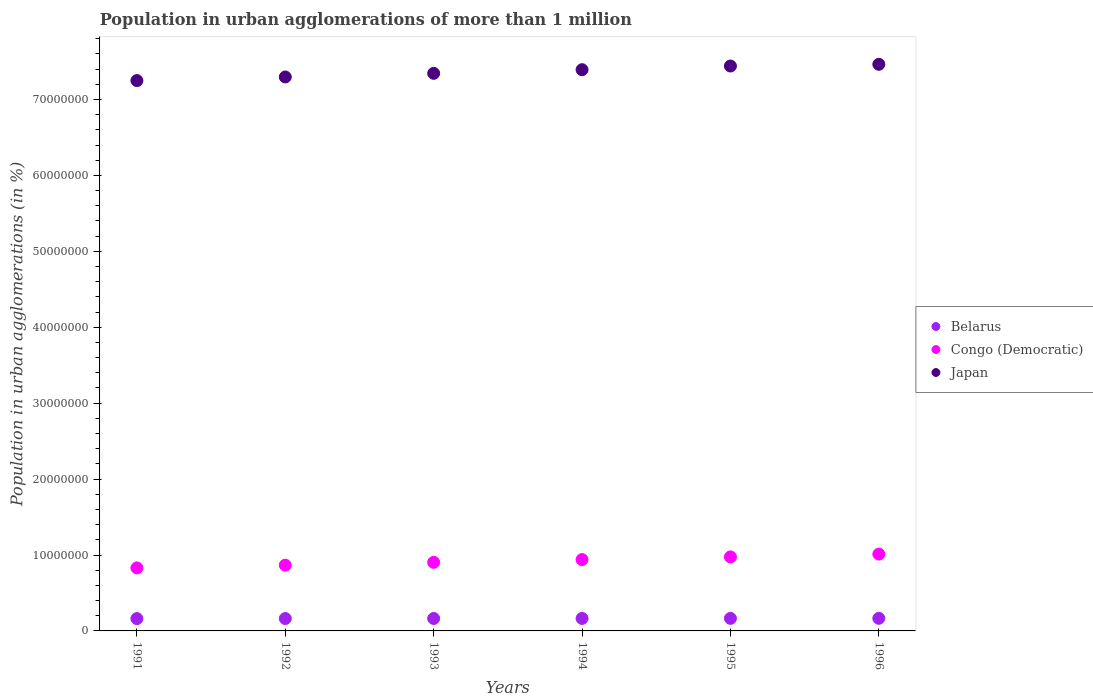Is the number of dotlines equal to the number of legend labels?
Offer a very short reply. Yes. What is the population in urban agglomerations in Japan in 1996?
Ensure brevity in your answer.  7.46e+07. Across all years, what is the maximum population in urban agglomerations in Japan?
Keep it short and to the point. 7.46e+07. Across all years, what is the minimum population in urban agglomerations in Belarus?
Your answer should be very brief. 1.62e+06. In which year was the population in urban agglomerations in Belarus minimum?
Give a very brief answer. 1991. What is the total population in urban agglomerations in Japan in the graph?
Make the answer very short. 4.42e+08. What is the difference between the population in urban agglomerations in Congo (Democratic) in 1991 and that in 1992?
Keep it short and to the point. -3.58e+05. What is the difference between the population in urban agglomerations in Congo (Democratic) in 1993 and the population in urban agglomerations in Belarus in 1994?
Provide a short and direct response. 7.39e+06. What is the average population in urban agglomerations in Belarus per year?
Offer a terse response. 1.64e+06. In the year 1996, what is the difference between the population in urban agglomerations in Belarus and population in urban agglomerations in Japan?
Your answer should be very brief. -7.30e+07. In how many years, is the population in urban agglomerations in Congo (Democratic) greater than 48000000 %?
Keep it short and to the point. 0. What is the ratio of the population in urban agglomerations in Congo (Democratic) in 1994 to that in 1996?
Your response must be concise. 0.93. Is the population in urban agglomerations in Japan in 1992 less than that in 1995?
Your answer should be very brief. Yes. What is the difference between the highest and the second highest population in urban agglomerations in Japan?
Make the answer very short. 2.27e+05. What is the difference between the highest and the lowest population in urban agglomerations in Congo (Democratic)?
Ensure brevity in your answer.  1.82e+06. In how many years, is the population in urban agglomerations in Belarus greater than the average population in urban agglomerations in Belarus taken over all years?
Make the answer very short. 3. Does the population in urban agglomerations in Congo (Democratic) monotonically increase over the years?
Provide a succinct answer. Yes. Is the population in urban agglomerations in Belarus strictly greater than the population in urban agglomerations in Japan over the years?
Provide a succinct answer. No. How many dotlines are there?
Make the answer very short. 3. Where does the legend appear in the graph?
Keep it short and to the point. Center right. What is the title of the graph?
Offer a terse response. Population in urban agglomerations of more than 1 million. Does "Aruba" appear as one of the legend labels in the graph?
Offer a very short reply. No. What is the label or title of the X-axis?
Offer a terse response. Years. What is the label or title of the Y-axis?
Keep it short and to the point. Population in urban agglomerations (in %). What is the Population in urban agglomerations (in %) of Belarus in 1991?
Ensure brevity in your answer.  1.62e+06. What is the Population in urban agglomerations (in %) of Congo (Democratic) in 1991?
Offer a terse response. 8.30e+06. What is the Population in urban agglomerations (in %) in Japan in 1991?
Make the answer very short. 7.25e+07. What is the Population in urban agglomerations (in %) of Belarus in 1992?
Give a very brief answer. 1.63e+06. What is the Population in urban agglomerations (in %) of Congo (Democratic) in 1992?
Provide a succinct answer. 8.66e+06. What is the Population in urban agglomerations (in %) of Japan in 1992?
Make the answer very short. 7.30e+07. What is the Population in urban agglomerations (in %) in Belarus in 1993?
Your answer should be compact. 1.64e+06. What is the Population in urban agglomerations (in %) in Congo (Democratic) in 1993?
Your answer should be compact. 9.04e+06. What is the Population in urban agglomerations (in %) in Japan in 1993?
Your answer should be very brief. 7.34e+07. What is the Population in urban agglomerations (in %) of Belarus in 1994?
Keep it short and to the point. 1.65e+06. What is the Population in urban agglomerations (in %) of Congo (Democratic) in 1994?
Give a very brief answer. 9.40e+06. What is the Population in urban agglomerations (in %) of Japan in 1994?
Provide a succinct answer. 7.39e+07. What is the Population in urban agglomerations (in %) of Belarus in 1995?
Provide a short and direct response. 1.65e+06. What is the Population in urban agglomerations (in %) in Congo (Democratic) in 1995?
Provide a succinct answer. 9.75e+06. What is the Population in urban agglomerations (in %) in Japan in 1995?
Give a very brief answer. 7.44e+07. What is the Population in urban agglomerations (in %) in Belarus in 1996?
Keep it short and to the point. 1.66e+06. What is the Population in urban agglomerations (in %) in Congo (Democratic) in 1996?
Your answer should be compact. 1.01e+07. What is the Population in urban agglomerations (in %) in Japan in 1996?
Your response must be concise. 7.46e+07. Across all years, what is the maximum Population in urban agglomerations (in %) of Belarus?
Make the answer very short. 1.66e+06. Across all years, what is the maximum Population in urban agglomerations (in %) in Congo (Democratic)?
Ensure brevity in your answer.  1.01e+07. Across all years, what is the maximum Population in urban agglomerations (in %) of Japan?
Provide a short and direct response. 7.46e+07. Across all years, what is the minimum Population in urban agglomerations (in %) in Belarus?
Your answer should be compact. 1.62e+06. Across all years, what is the minimum Population in urban agglomerations (in %) in Congo (Democratic)?
Offer a terse response. 8.30e+06. Across all years, what is the minimum Population in urban agglomerations (in %) in Japan?
Your answer should be very brief. 7.25e+07. What is the total Population in urban agglomerations (in %) in Belarus in the graph?
Make the answer very short. 9.86e+06. What is the total Population in urban agglomerations (in %) in Congo (Democratic) in the graph?
Keep it short and to the point. 5.53e+07. What is the total Population in urban agglomerations (in %) of Japan in the graph?
Your response must be concise. 4.42e+08. What is the difference between the Population in urban agglomerations (in %) of Belarus in 1991 and that in 1992?
Provide a succinct answer. -7221. What is the difference between the Population in urban agglomerations (in %) in Congo (Democratic) in 1991 and that in 1992?
Provide a succinct answer. -3.58e+05. What is the difference between the Population in urban agglomerations (in %) of Japan in 1991 and that in 1992?
Ensure brevity in your answer.  -4.75e+05. What is the difference between the Population in urban agglomerations (in %) of Belarus in 1991 and that in 1993?
Give a very brief answer. -1.45e+04. What is the difference between the Population in urban agglomerations (in %) of Congo (Democratic) in 1991 and that in 1993?
Provide a short and direct response. -7.33e+05. What is the difference between the Population in urban agglomerations (in %) in Japan in 1991 and that in 1993?
Your answer should be compact. -9.52e+05. What is the difference between the Population in urban agglomerations (in %) in Belarus in 1991 and that in 1994?
Ensure brevity in your answer.  -2.17e+04. What is the difference between the Population in urban agglomerations (in %) of Congo (Democratic) in 1991 and that in 1994?
Offer a terse response. -1.10e+06. What is the difference between the Population in urban agglomerations (in %) of Japan in 1991 and that in 1994?
Make the answer very short. -1.43e+06. What is the difference between the Population in urban agglomerations (in %) in Belarus in 1991 and that in 1995?
Provide a short and direct response. -2.90e+04. What is the difference between the Population in urban agglomerations (in %) in Congo (Democratic) in 1991 and that in 1995?
Offer a terse response. -1.45e+06. What is the difference between the Population in urban agglomerations (in %) of Japan in 1991 and that in 1995?
Make the answer very short. -1.92e+06. What is the difference between the Population in urban agglomerations (in %) of Belarus in 1991 and that in 1996?
Give a very brief answer. -3.64e+04. What is the difference between the Population in urban agglomerations (in %) of Congo (Democratic) in 1991 and that in 1996?
Keep it short and to the point. -1.82e+06. What is the difference between the Population in urban agglomerations (in %) of Japan in 1991 and that in 1996?
Make the answer very short. -2.15e+06. What is the difference between the Population in urban agglomerations (in %) of Belarus in 1992 and that in 1993?
Provide a short and direct response. -7234. What is the difference between the Population in urban agglomerations (in %) of Congo (Democratic) in 1992 and that in 1993?
Provide a short and direct response. -3.74e+05. What is the difference between the Population in urban agglomerations (in %) of Japan in 1992 and that in 1993?
Keep it short and to the point. -4.77e+05. What is the difference between the Population in urban agglomerations (in %) of Belarus in 1992 and that in 1994?
Your answer should be compact. -1.45e+04. What is the difference between the Population in urban agglomerations (in %) in Congo (Democratic) in 1992 and that in 1994?
Give a very brief answer. -7.38e+05. What is the difference between the Population in urban agglomerations (in %) in Japan in 1992 and that in 1994?
Provide a short and direct response. -9.58e+05. What is the difference between the Population in urban agglomerations (in %) in Belarus in 1992 and that in 1995?
Offer a terse response. -2.18e+04. What is the difference between the Population in urban agglomerations (in %) in Congo (Democratic) in 1992 and that in 1995?
Make the answer very short. -1.09e+06. What is the difference between the Population in urban agglomerations (in %) in Japan in 1992 and that in 1995?
Provide a succinct answer. -1.44e+06. What is the difference between the Population in urban agglomerations (in %) of Belarus in 1992 and that in 1996?
Provide a succinct answer. -2.92e+04. What is the difference between the Population in urban agglomerations (in %) in Congo (Democratic) in 1992 and that in 1996?
Keep it short and to the point. -1.46e+06. What is the difference between the Population in urban agglomerations (in %) in Japan in 1992 and that in 1996?
Give a very brief answer. -1.67e+06. What is the difference between the Population in urban agglomerations (in %) in Belarus in 1993 and that in 1994?
Offer a very short reply. -7276. What is the difference between the Population in urban agglomerations (in %) of Congo (Democratic) in 1993 and that in 1994?
Provide a short and direct response. -3.63e+05. What is the difference between the Population in urban agglomerations (in %) of Japan in 1993 and that in 1994?
Your answer should be very brief. -4.81e+05. What is the difference between the Population in urban agglomerations (in %) in Belarus in 1993 and that in 1995?
Keep it short and to the point. -1.46e+04. What is the difference between the Population in urban agglomerations (in %) of Congo (Democratic) in 1993 and that in 1995?
Provide a short and direct response. -7.15e+05. What is the difference between the Population in urban agglomerations (in %) of Japan in 1993 and that in 1995?
Provide a succinct answer. -9.65e+05. What is the difference between the Population in urban agglomerations (in %) in Belarus in 1993 and that in 1996?
Your answer should be compact. -2.19e+04. What is the difference between the Population in urban agglomerations (in %) in Congo (Democratic) in 1993 and that in 1996?
Provide a short and direct response. -1.09e+06. What is the difference between the Population in urban agglomerations (in %) of Japan in 1993 and that in 1996?
Provide a succinct answer. -1.19e+06. What is the difference between the Population in urban agglomerations (in %) in Belarus in 1994 and that in 1995?
Your response must be concise. -7308. What is the difference between the Population in urban agglomerations (in %) in Congo (Democratic) in 1994 and that in 1995?
Provide a short and direct response. -3.52e+05. What is the difference between the Population in urban agglomerations (in %) in Japan in 1994 and that in 1995?
Provide a short and direct response. -4.84e+05. What is the difference between the Population in urban agglomerations (in %) in Belarus in 1994 and that in 1996?
Your answer should be very brief. -1.47e+04. What is the difference between the Population in urban agglomerations (in %) of Congo (Democratic) in 1994 and that in 1996?
Your response must be concise. -7.22e+05. What is the difference between the Population in urban agglomerations (in %) in Japan in 1994 and that in 1996?
Provide a succinct answer. -7.12e+05. What is the difference between the Population in urban agglomerations (in %) in Belarus in 1995 and that in 1996?
Your answer should be compact. -7351. What is the difference between the Population in urban agglomerations (in %) of Congo (Democratic) in 1995 and that in 1996?
Offer a terse response. -3.70e+05. What is the difference between the Population in urban agglomerations (in %) in Japan in 1995 and that in 1996?
Your answer should be compact. -2.27e+05. What is the difference between the Population in urban agglomerations (in %) of Belarus in 1991 and the Population in urban agglomerations (in %) of Congo (Democratic) in 1992?
Ensure brevity in your answer.  -7.04e+06. What is the difference between the Population in urban agglomerations (in %) in Belarus in 1991 and the Population in urban agglomerations (in %) in Japan in 1992?
Make the answer very short. -7.13e+07. What is the difference between the Population in urban agglomerations (in %) in Congo (Democratic) in 1991 and the Population in urban agglomerations (in %) in Japan in 1992?
Your response must be concise. -6.47e+07. What is the difference between the Population in urban agglomerations (in %) in Belarus in 1991 and the Population in urban agglomerations (in %) in Congo (Democratic) in 1993?
Your answer should be very brief. -7.41e+06. What is the difference between the Population in urban agglomerations (in %) of Belarus in 1991 and the Population in urban agglomerations (in %) of Japan in 1993?
Provide a short and direct response. -7.18e+07. What is the difference between the Population in urban agglomerations (in %) of Congo (Democratic) in 1991 and the Population in urban agglomerations (in %) of Japan in 1993?
Offer a very short reply. -6.51e+07. What is the difference between the Population in urban agglomerations (in %) in Belarus in 1991 and the Population in urban agglomerations (in %) in Congo (Democratic) in 1994?
Provide a succinct answer. -7.77e+06. What is the difference between the Population in urban agglomerations (in %) of Belarus in 1991 and the Population in urban agglomerations (in %) of Japan in 1994?
Offer a terse response. -7.23e+07. What is the difference between the Population in urban agglomerations (in %) in Congo (Democratic) in 1991 and the Population in urban agglomerations (in %) in Japan in 1994?
Offer a very short reply. -6.56e+07. What is the difference between the Population in urban agglomerations (in %) of Belarus in 1991 and the Population in urban agglomerations (in %) of Congo (Democratic) in 1995?
Make the answer very short. -8.13e+06. What is the difference between the Population in urban agglomerations (in %) in Belarus in 1991 and the Population in urban agglomerations (in %) in Japan in 1995?
Your answer should be very brief. -7.28e+07. What is the difference between the Population in urban agglomerations (in %) in Congo (Democratic) in 1991 and the Population in urban agglomerations (in %) in Japan in 1995?
Make the answer very short. -6.61e+07. What is the difference between the Population in urban agglomerations (in %) of Belarus in 1991 and the Population in urban agglomerations (in %) of Congo (Democratic) in 1996?
Keep it short and to the point. -8.50e+06. What is the difference between the Population in urban agglomerations (in %) of Belarus in 1991 and the Population in urban agglomerations (in %) of Japan in 1996?
Your answer should be very brief. -7.30e+07. What is the difference between the Population in urban agglomerations (in %) of Congo (Democratic) in 1991 and the Population in urban agglomerations (in %) of Japan in 1996?
Offer a terse response. -6.63e+07. What is the difference between the Population in urban agglomerations (in %) of Belarus in 1992 and the Population in urban agglomerations (in %) of Congo (Democratic) in 1993?
Ensure brevity in your answer.  -7.40e+06. What is the difference between the Population in urban agglomerations (in %) in Belarus in 1992 and the Population in urban agglomerations (in %) in Japan in 1993?
Your answer should be very brief. -7.18e+07. What is the difference between the Population in urban agglomerations (in %) in Congo (Democratic) in 1992 and the Population in urban agglomerations (in %) in Japan in 1993?
Provide a succinct answer. -6.48e+07. What is the difference between the Population in urban agglomerations (in %) in Belarus in 1992 and the Population in urban agglomerations (in %) in Congo (Democratic) in 1994?
Give a very brief answer. -7.77e+06. What is the difference between the Population in urban agglomerations (in %) in Belarus in 1992 and the Population in urban agglomerations (in %) in Japan in 1994?
Make the answer very short. -7.23e+07. What is the difference between the Population in urban agglomerations (in %) in Congo (Democratic) in 1992 and the Population in urban agglomerations (in %) in Japan in 1994?
Your answer should be compact. -6.53e+07. What is the difference between the Population in urban agglomerations (in %) of Belarus in 1992 and the Population in urban agglomerations (in %) of Congo (Democratic) in 1995?
Your answer should be very brief. -8.12e+06. What is the difference between the Population in urban agglomerations (in %) of Belarus in 1992 and the Population in urban agglomerations (in %) of Japan in 1995?
Your response must be concise. -7.28e+07. What is the difference between the Population in urban agglomerations (in %) of Congo (Democratic) in 1992 and the Population in urban agglomerations (in %) of Japan in 1995?
Your response must be concise. -6.58e+07. What is the difference between the Population in urban agglomerations (in %) of Belarus in 1992 and the Population in urban agglomerations (in %) of Congo (Democratic) in 1996?
Ensure brevity in your answer.  -8.49e+06. What is the difference between the Population in urban agglomerations (in %) of Belarus in 1992 and the Population in urban agglomerations (in %) of Japan in 1996?
Ensure brevity in your answer.  -7.30e+07. What is the difference between the Population in urban agglomerations (in %) in Congo (Democratic) in 1992 and the Population in urban agglomerations (in %) in Japan in 1996?
Your answer should be very brief. -6.60e+07. What is the difference between the Population in urban agglomerations (in %) in Belarus in 1993 and the Population in urban agglomerations (in %) in Congo (Democratic) in 1994?
Your answer should be compact. -7.76e+06. What is the difference between the Population in urban agglomerations (in %) of Belarus in 1993 and the Population in urban agglomerations (in %) of Japan in 1994?
Provide a short and direct response. -7.23e+07. What is the difference between the Population in urban agglomerations (in %) in Congo (Democratic) in 1993 and the Population in urban agglomerations (in %) in Japan in 1994?
Provide a succinct answer. -6.49e+07. What is the difference between the Population in urban agglomerations (in %) of Belarus in 1993 and the Population in urban agglomerations (in %) of Congo (Democratic) in 1995?
Keep it short and to the point. -8.11e+06. What is the difference between the Population in urban agglomerations (in %) of Belarus in 1993 and the Population in urban agglomerations (in %) of Japan in 1995?
Keep it short and to the point. -7.28e+07. What is the difference between the Population in urban agglomerations (in %) in Congo (Democratic) in 1993 and the Population in urban agglomerations (in %) in Japan in 1995?
Your answer should be very brief. -6.54e+07. What is the difference between the Population in urban agglomerations (in %) in Belarus in 1993 and the Population in urban agglomerations (in %) in Congo (Democratic) in 1996?
Make the answer very short. -8.48e+06. What is the difference between the Population in urban agglomerations (in %) of Belarus in 1993 and the Population in urban agglomerations (in %) of Japan in 1996?
Offer a terse response. -7.30e+07. What is the difference between the Population in urban agglomerations (in %) of Congo (Democratic) in 1993 and the Population in urban agglomerations (in %) of Japan in 1996?
Keep it short and to the point. -6.56e+07. What is the difference between the Population in urban agglomerations (in %) of Belarus in 1994 and the Population in urban agglomerations (in %) of Congo (Democratic) in 1995?
Your response must be concise. -8.10e+06. What is the difference between the Population in urban agglomerations (in %) in Belarus in 1994 and the Population in urban agglomerations (in %) in Japan in 1995?
Your answer should be compact. -7.28e+07. What is the difference between the Population in urban agglomerations (in %) of Congo (Democratic) in 1994 and the Population in urban agglomerations (in %) of Japan in 1995?
Make the answer very short. -6.50e+07. What is the difference between the Population in urban agglomerations (in %) in Belarus in 1994 and the Population in urban agglomerations (in %) in Congo (Democratic) in 1996?
Your answer should be very brief. -8.47e+06. What is the difference between the Population in urban agglomerations (in %) in Belarus in 1994 and the Population in urban agglomerations (in %) in Japan in 1996?
Your answer should be very brief. -7.30e+07. What is the difference between the Population in urban agglomerations (in %) of Congo (Democratic) in 1994 and the Population in urban agglomerations (in %) of Japan in 1996?
Your response must be concise. -6.52e+07. What is the difference between the Population in urban agglomerations (in %) of Belarus in 1995 and the Population in urban agglomerations (in %) of Congo (Democratic) in 1996?
Your answer should be compact. -8.47e+06. What is the difference between the Population in urban agglomerations (in %) of Belarus in 1995 and the Population in urban agglomerations (in %) of Japan in 1996?
Offer a terse response. -7.30e+07. What is the difference between the Population in urban agglomerations (in %) of Congo (Democratic) in 1995 and the Population in urban agglomerations (in %) of Japan in 1996?
Offer a terse response. -6.49e+07. What is the average Population in urban agglomerations (in %) in Belarus per year?
Ensure brevity in your answer.  1.64e+06. What is the average Population in urban agglomerations (in %) of Congo (Democratic) per year?
Offer a terse response. 9.21e+06. What is the average Population in urban agglomerations (in %) in Japan per year?
Make the answer very short. 7.37e+07. In the year 1991, what is the difference between the Population in urban agglomerations (in %) of Belarus and Population in urban agglomerations (in %) of Congo (Democratic)?
Give a very brief answer. -6.68e+06. In the year 1991, what is the difference between the Population in urban agglomerations (in %) of Belarus and Population in urban agglomerations (in %) of Japan?
Offer a terse response. -7.09e+07. In the year 1991, what is the difference between the Population in urban agglomerations (in %) of Congo (Democratic) and Population in urban agglomerations (in %) of Japan?
Your response must be concise. -6.42e+07. In the year 1992, what is the difference between the Population in urban agglomerations (in %) in Belarus and Population in urban agglomerations (in %) in Congo (Democratic)?
Offer a terse response. -7.03e+06. In the year 1992, what is the difference between the Population in urban agglomerations (in %) in Belarus and Population in urban agglomerations (in %) in Japan?
Give a very brief answer. -7.13e+07. In the year 1992, what is the difference between the Population in urban agglomerations (in %) in Congo (Democratic) and Population in urban agglomerations (in %) in Japan?
Keep it short and to the point. -6.43e+07. In the year 1993, what is the difference between the Population in urban agglomerations (in %) in Belarus and Population in urban agglomerations (in %) in Congo (Democratic)?
Your answer should be compact. -7.40e+06. In the year 1993, what is the difference between the Population in urban agglomerations (in %) in Belarus and Population in urban agglomerations (in %) in Japan?
Make the answer very short. -7.18e+07. In the year 1993, what is the difference between the Population in urban agglomerations (in %) of Congo (Democratic) and Population in urban agglomerations (in %) of Japan?
Your answer should be compact. -6.44e+07. In the year 1994, what is the difference between the Population in urban agglomerations (in %) of Belarus and Population in urban agglomerations (in %) of Congo (Democratic)?
Offer a terse response. -7.75e+06. In the year 1994, what is the difference between the Population in urban agglomerations (in %) of Belarus and Population in urban agglomerations (in %) of Japan?
Your answer should be very brief. -7.23e+07. In the year 1994, what is the difference between the Population in urban agglomerations (in %) in Congo (Democratic) and Population in urban agglomerations (in %) in Japan?
Provide a succinct answer. -6.45e+07. In the year 1995, what is the difference between the Population in urban agglomerations (in %) in Belarus and Population in urban agglomerations (in %) in Congo (Democratic)?
Your answer should be compact. -8.10e+06. In the year 1995, what is the difference between the Population in urban agglomerations (in %) in Belarus and Population in urban agglomerations (in %) in Japan?
Offer a very short reply. -7.28e+07. In the year 1995, what is the difference between the Population in urban agglomerations (in %) in Congo (Democratic) and Population in urban agglomerations (in %) in Japan?
Your response must be concise. -6.47e+07. In the year 1996, what is the difference between the Population in urban agglomerations (in %) in Belarus and Population in urban agglomerations (in %) in Congo (Democratic)?
Keep it short and to the point. -8.46e+06. In the year 1996, what is the difference between the Population in urban agglomerations (in %) of Belarus and Population in urban agglomerations (in %) of Japan?
Make the answer very short. -7.30e+07. In the year 1996, what is the difference between the Population in urban agglomerations (in %) in Congo (Democratic) and Population in urban agglomerations (in %) in Japan?
Offer a very short reply. -6.45e+07. What is the ratio of the Population in urban agglomerations (in %) of Belarus in 1991 to that in 1992?
Your response must be concise. 1. What is the ratio of the Population in urban agglomerations (in %) in Congo (Democratic) in 1991 to that in 1992?
Offer a terse response. 0.96. What is the ratio of the Population in urban agglomerations (in %) in Belarus in 1991 to that in 1993?
Your response must be concise. 0.99. What is the ratio of the Population in urban agglomerations (in %) of Congo (Democratic) in 1991 to that in 1993?
Keep it short and to the point. 0.92. What is the ratio of the Population in urban agglomerations (in %) in Japan in 1991 to that in 1993?
Keep it short and to the point. 0.99. What is the ratio of the Population in urban agglomerations (in %) in Congo (Democratic) in 1991 to that in 1994?
Give a very brief answer. 0.88. What is the ratio of the Population in urban agglomerations (in %) of Japan in 1991 to that in 1994?
Offer a very short reply. 0.98. What is the ratio of the Population in urban agglomerations (in %) of Belarus in 1991 to that in 1995?
Your answer should be very brief. 0.98. What is the ratio of the Population in urban agglomerations (in %) in Congo (Democratic) in 1991 to that in 1995?
Your response must be concise. 0.85. What is the ratio of the Population in urban agglomerations (in %) in Japan in 1991 to that in 1995?
Keep it short and to the point. 0.97. What is the ratio of the Population in urban agglomerations (in %) in Belarus in 1991 to that in 1996?
Keep it short and to the point. 0.98. What is the ratio of the Population in urban agglomerations (in %) of Congo (Democratic) in 1991 to that in 1996?
Your answer should be very brief. 0.82. What is the ratio of the Population in urban agglomerations (in %) of Japan in 1991 to that in 1996?
Provide a succinct answer. 0.97. What is the ratio of the Population in urban agglomerations (in %) of Belarus in 1992 to that in 1993?
Offer a very short reply. 1. What is the ratio of the Population in urban agglomerations (in %) of Congo (Democratic) in 1992 to that in 1993?
Provide a succinct answer. 0.96. What is the ratio of the Population in urban agglomerations (in %) of Japan in 1992 to that in 1993?
Your response must be concise. 0.99. What is the ratio of the Population in urban agglomerations (in %) in Congo (Democratic) in 1992 to that in 1994?
Offer a terse response. 0.92. What is the ratio of the Population in urban agglomerations (in %) of Belarus in 1992 to that in 1995?
Offer a terse response. 0.99. What is the ratio of the Population in urban agglomerations (in %) of Congo (Democratic) in 1992 to that in 1995?
Give a very brief answer. 0.89. What is the ratio of the Population in urban agglomerations (in %) in Japan in 1992 to that in 1995?
Offer a terse response. 0.98. What is the ratio of the Population in urban agglomerations (in %) of Belarus in 1992 to that in 1996?
Your answer should be very brief. 0.98. What is the ratio of the Population in urban agglomerations (in %) of Congo (Democratic) in 1992 to that in 1996?
Provide a succinct answer. 0.86. What is the ratio of the Population in urban agglomerations (in %) of Japan in 1992 to that in 1996?
Provide a succinct answer. 0.98. What is the ratio of the Population in urban agglomerations (in %) in Belarus in 1993 to that in 1994?
Keep it short and to the point. 1. What is the ratio of the Population in urban agglomerations (in %) of Congo (Democratic) in 1993 to that in 1994?
Offer a very short reply. 0.96. What is the ratio of the Population in urban agglomerations (in %) of Belarus in 1993 to that in 1995?
Your response must be concise. 0.99. What is the ratio of the Population in urban agglomerations (in %) in Congo (Democratic) in 1993 to that in 1995?
Ensure brevity in your answer.  0.93. What is the ratio of the Population in urban agglomerations (in %) of Japan in 1993 to that in 1995?
Ensure brevity in your answer.  0.99. What is the ratio of the Population in urban agglomerations (in %) of Congo (Democratic) in 1993 to that in 1996?
Provide a succinct answer. 0.89. What is the ratio of the Population in urban agglomerations (in %) of Japan in 1993 to that in 1996?
Give a very brief answer. 0.98. What is the ratio of the Population in urban agglomerations (in %) in Congo (Democratic) in 1994 to that in 1995?
Ensure brevity in your answer.  0.96. What is the ratio of the Population in urban agglomerations (in %) of Japan in 1994 to that in 1995?
Make the answer very short. 0.99. What is the ratio of the Population in urban agglomerations (in %) in Belarus in 1994 to that in 1996?
Offer a very short reply. 0.99. What is the ratio of the Population in urban agglomerations (in %) of Congo (Democratic) in 1994 to that in 1996?
Your answer should be compact. 0.93. What is the ratio of the Population in urban agglomerations (in %) in Congo (Democratic) in 1995 to that in 1996?
Your response must be concise. 0.96. What is the ratio of the Population in urban agglomerations (in %) in Japan in 1995 to that in 1996?
Provide a short and direct response. 1. What is the difference between the highest and the second highest Population in urban agglomerations (in %) of Belarus?
Offer a terse response. 7351. What is the difference between the highest and the second highest Population in urban agglomerations (in %) in Congo (Democratic)?
Ensure brevity in your answer.  3.70e+05. What is the difference between the highest and the second highest Population in urban agglomerations (in %) of Japan?
Ensure brevity in your answer.  2.27e+05. What is the difference between the highest and the lowest Population in urban agglomerations (in %) of Belarus?
Your answer should be compact. 3.64e+04. What is the difference between the highest and the lowest Population in urban agglomerations (in %) in Congo (Democratic)?
Keep it short and to the point. 1.82e+06. What is the difference between the highest and the lowest Population in urban agglomerations (in %) in Japan?
Provide a succinct answer. 2.15e+06. 